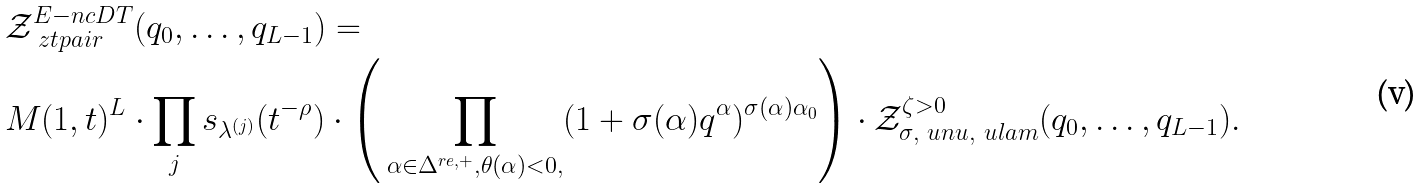<formula> <loc_0><loc_0><loc_500><loc_500>& \mathcal { Z } ^ { E - n c D T } _ { \ z t p a i r } ( q _ { 0 } , \dots , q _ { L - 1 } ) = \\ & M ( 1 , t ) ^ { L } \cdot \prod _ { j } s _ { \lambda ^ { ( j ) } } ( t ^ { - \rho } ) \cdot \left ( \, \prod _ { \alpha \in \Delta ^ { r e , + } , \theta ( \alpha ) < 0 , } ( 1 + \sigma ( \alpha ) q ^ { \alpha } ) ^ { \sigma ( \alpha ) \alpha _ { 0 } } \right ) \cdot \mathcal { Z } ^ { \zeta > 0 } _ { \sigma , \ u n u , \ u l a m } ( q _ { 0 } , \dots , q _ { L - 1 } ) .</formula> 